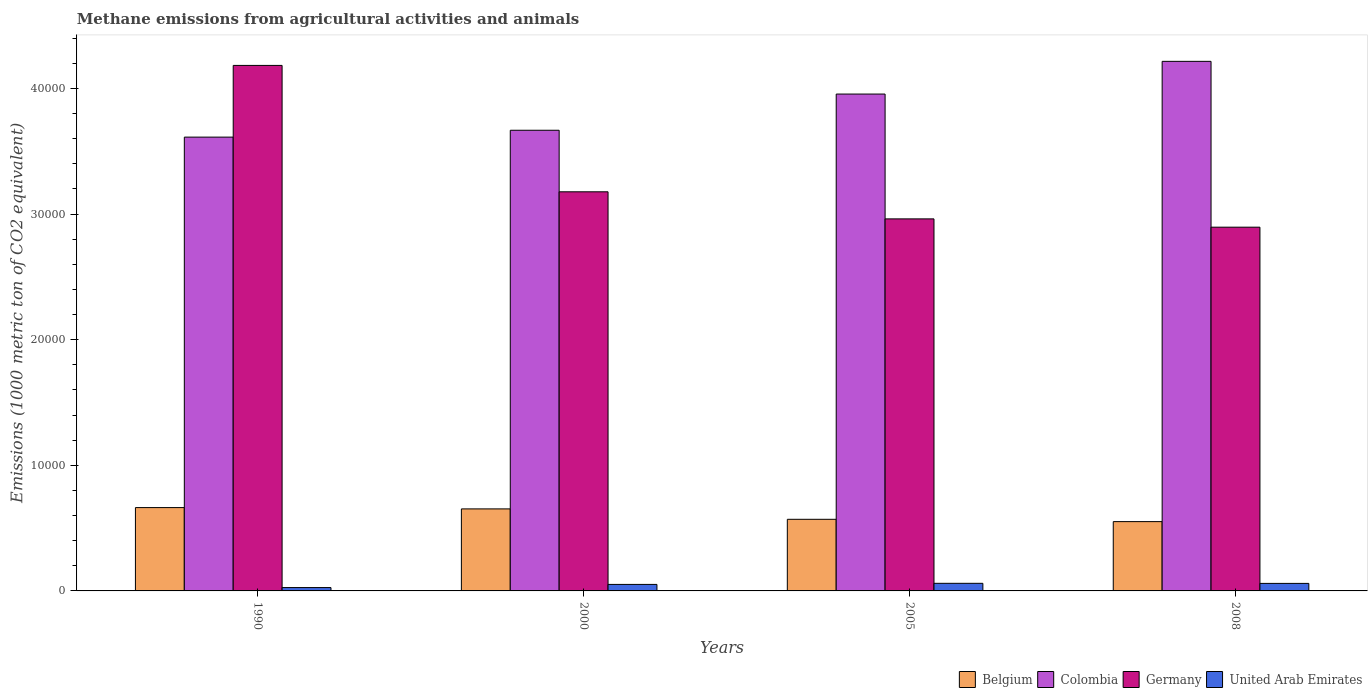Are the number of bars per tick equal to the number of legend labels?
Offer a very short reply. Yes. How many bars are there on the 3rd tick from the left?
Offer a terse response. 4. How many bars are there on the 1st tick from the right?
Give a very brief answer. 4. What is the amount of methane emitted in United Arab Emirates in 2005?
Give a very brief answer. 604.7. Across all years, what is the maximum amount of methane emitted in United Arab Emirates?
Provide a short and direct response. 604.7. Across all years, what is the minimum amount of methane emitted in United Arab Emirates?
Ensure brevity in your answer.  266.3. In which year was the amount of methane emitted in Germany maximum?
Your answer should be very brief. 1990. What is the total amount of methane emitted in Belgium in the graph?
Your response must be concise. 2.44e+04. What is the difference between the amount of methane emitted in Belgium in 1990 and that in 2000?
Provide a short and direct response. 104.8. What is the difference between the amount of methane emitted in Colombia in 2000 and the amount of methane emitted in Belgium in 1990?
Keep it short and to the point. 3.00e+04. What is the average amount of methane emitted in Belgium per year?
Give a very brief answer. 6095.67. In the year 2005, what is the difference between the amount of methane emitted in Belgium and amount of methane emitted in Colombia?
Your answer should be compact. -3.39e+04. What is the ratio of the amount of methane emitted in United Arab Emirates in 2000 to that in 2008?
Make the answer very short. 0.86. Is the amount of methane emitted in Belgium in 1990 less than that in 2008?
Make the answer very short. No. Is the difference between the amount of methane emitted in Belgium in 1990 and 2008 greater than the difference between the amount of methane emitted in Colombia in 1990 and 2008?
Give a very brief answer. Yes. What is the difference between the highest and the second highest amount of methane emitted in Colombia?
Your answer should be very brief. 2603.6. What is the difference between the highest and the lowest amount of methane emitted in Germany?
Your answer should be compact. 1.29e+04. What does the 4th bar from the left in 2005 represents?
Keep it short and to the point. United Arab Emirates. What does the 1st bar from the right in 1990 represents?
Offer a terse response. United Arab Emirates. Are all the bars in the graph horizontal?
Give a very brief answer. No. How many years are there in the graph?
Give a very brief answer. 4. What is the difference between two consecutive major ticks on the Y-axis?
Offer a very short reply. 10000. Does the graph contain grids?
Keep it short and to the point. No. Where does the legend appear in the graph?
Make the answer very short. Bottom right. What is the title of the graph?
Your answer should be compact. Methane emissions from agricultural activities and animals. What is the label or title of the X-axis?
Offer a very short reply. Years. What is the label or title of the Y-axis?
Your answer should be compact. Emissions (1000 metric ton of CO2 equivalent). What is the Emissions (1000 metric ton of CO2 equivalent) in Belgium in 1990?
Ensure brevity in your answer.  6634.3. What is the Emissions (1000 metric ton of CO2 equivalent) in Colombia in 1990?
Keep it short and to the point. 3.61e+04. What is the Emissions (1000 metric ton of CO2 equivalent) in Germany in 1990?
Provide a short and direct response. 4.18e+04. What is the Emissions (1000 metric ton of CO2 equivalent) of United Arab Emirates in 1990?
Keep it short and to the point. 266.3. What is the Emissions (1000 metric ton of CO2 equivalent) of Belgium in 2000?
Your answer should be very brief. 6529.5. What is the Emissions (1000 metric ton of CO2 equivalent) of Colombia in 2000?
Offer a terse response. 3.67e+04. What is the Emissions (1000 metric ton of CO2 equivalent) of Germany in 2000?
Your answer should be very brief. 3.18e+04. What is the Emissions (1000 metric ton of CO2 equivalent) of United Arab Emirates in 2000?
Offer a very short reply. 518. What is the Emissions (1000 metric ton of CO2 equivalent) in Belgium in 2005?
Your answer should be compact. 5701.8. What is the Emissions (1000 metric ton of CO2 equivalent) in Colombia in 2005?
Ensure brevity in your answer.  3.96e+04. What is the Emissions (1000 metric ton of CO2 equivalent) of Germany in 2005?
Make the answer very short. 2.96e+04. What is the Emissions (1000 metric ton of CO2 equivalent) of United Arab Emirates in 2005?
Make the answer very short. 604.7. What is the Emissions (1000 metric ton of CO2 equivalent) in Belgium in 2008?
Your answer should be compact. 5517.1. What is the Emissions (1000 metric ton of CO2 equivalent) in Colombia in 2008?
Offer a very short reply. 4.22e+04. What is the Emissions (1000 metric ton of CO2 equivalent) in Germany in 2008?
Make the answer very short. 2.90e+04. What is the Emissions (1000 metric ton of CO2 equivalent) in United Arab Emirates in 2008?
Provide a short and direct response. 599.2. Across all years, what is the maximum Emissions (1000 metric ton of CO2 equivalent) in Belgium?
Keep it short and to the point. 6634.3. Across all years, what is the maximum Emissions (1000 metric ton of CO2 equivalent) of Colombia?
Offer a very short reply. 4.22e+04. Across all years, what is the maximum Emissions (1000 metric ton of CO2 equivalent) of Germany?
Ensure brevity in your answer.  4.18e+04. Across all years, what is the maximum Emissions (1000 metric ton of CO2 equivalent) in United Arab Emirates?
Give a very brief answer. 604.7. Across all years, what is the minimum Emissions (1000 metric ton of CO2 equivalent) of Belgium?
Your response must be concise. 5517.1. Across all years, what is the minimum Emissions (1000 metric ton of CO2 equivalent) in Colombia?
Offer a terse response. 3.61e+04. Across all years, what is the minimum Emissions (1000 metric ton of CO2 equivalent) in Germany?
Keep it short and to the point. 2.90e+04. Across all years, what is the minimum Emissions (1000 metric ton of CO2 equivalent) in United Arab Emirates?
Make the answer very short. 266.3. What is the total Emissions (1000 metric ton of CO2 equivalent) in Belgium in the graph?
Your answer should be very brief. 2.44e+04. What is the total Emissions (1000 metric ton of CO2 equivalent) of Colombia in the graph?
Keep it short and to the point. 1.55e+05. What is the total Emissions (1000 metric ton of CO2 equivalent) in Germany in the graph?
Your answer should be compact. 1.32e+05. What is the total Emissions (1000 metric ton of CO2 equivalent) in United Arab Emirates in the graph?
Offer a terse response. 1988.2. What is the difference between the Emissions (1000 metric ton of CO2 equivalent) in Belgium in 1990 and that in 2000?
Keep it short and to the point. 104.8. What is the difference between the Emissions (1000 metric ton of CO2 equivalent) of Colombia in 1990 and that in 2000?
Your answer should be compact. -546.7. What is the difference between the Emissions (1000 metric ton of CO2 equivalent) of Germany in 1990 and that in 2000?
Your answer should be very brief. 1.01e+04. What is the difference between the Emissions (1000 metric ton of CO2 equivalent) in United Arab Emirates in 1990 and that in 2000?
Ensure brevity in your answer.  -251.7. What is the difference between the Emissions (1000 metric ton of CO2 equivalent) of Belgium in 1990 and that in 2005?
Give a very brief answer. 932.5. What is the difference between the Emissions (1000 metric ton of CO2 equivalent) in Colombia in 1990 and that in 2005?
Your answer should be very brief. -3428.3. What is the difference between the Emissions (1000 metric ton of CO2 equivalent) in Germany in 1990 and that in 2005?
Your answer should be compact. 1.22e+04. What is the difference between the Emissions (1000 metric ton of CO2 equivalent) in United Arab Emirates in 1990 and that in 2005?
Offer a terse response. -338.4. What is the difference between the Emissions (1000 metric ton of CO2 equivalent) of Belgium in 1990 and that in 2008?
Offer a very short reply. 1117.2. What is the difference between the Emissions (1000 metric ton of CO2 equivalent) in Colombia in 1990 and that in 2008?
Keep it short and to the point. -6031.9. What is the difference between the Emissions (1000 metric ton of CO2 equivalent) of Germany in 1990 and that in 2008?
Provide a short and direct response. 1.29e+04. What is the difference between the Emissions (1000 metric ton of CO2 equivalent) of United Arab Emirates in 1990 and that in 2008?
Make the answer very short. -332.9. What is the difference between the Emissions (1000 metric ton of CO2 equivalent) of Belgium in 2000 and that in 2005?
Your answer should be compact. 827.7. What is the difference between the Emissions (1000 metric ton of CO2 equivalent) of Colombia in 2000 and that in 2005?
Your answer should be compact. -2881.6. What is the difference between the Emissions (1000 metric ton of CO2 equivalent) in Germany in 2000 and that in 2005?
Make the answer very short. 2155.4. What is the difference between the Emissions (1000 metric ton of CO2 equivalent) in United Arab Emirates in 2000 and that in 2005?
Make the answer very short. -86.7. What is the difference between the Emissions (1000 metric ton of CO2 equivalent) in Belgium in 2000 and that in 2008?
Your answer should be compact. 1012.4. What is the difference between the Emissions (1000 metric ton of CO2 equivalent) in Colombia in 2000 and that in 2008?
Your answer should be very brief. -5485.2. What is the difference between the Emissions (1000 metric ton of CO2 equivalent) in Germany in 2000 and that in 2008?
Your answer should be very brief. 2816.4. What is the difference between the Emissions (1000 metric ton of CO2 equivalent) of United Arab Emirates in 2000 and that in 2008?
Keep it short and to the point. -81.2. What is the difference between the Emissions (1000 metric ton of CO2 equivalent) of Belgium in 2005 and that in 2008?
Offer a terse response. 184.7. What is the difference between the Emissions (1000 metric ton of CO2 equivalent) in Colombia in 2005 and that in 2008?
Offer a terse response. -2603.6. What is the difference between the Emissions (1000 metric ton of CO2 equivalent) of Germany in 2005 and that in 2008?
Keep it short and to the point. 661. What is the difference between the Emissions (1000 metric ton of CO2 equivalent) of United Arab Emirates in 2005 and that in 2008?
Offer a very short reply. 5.5. What is the difference between the Emissions (1000 metric ton of CO2 equivalent) of Belgium in 1990 and the Emissions (1000 metric ton of CO2 equivalent) of Colombia in 2000?
Your answer should be compact. -3.00e+04. What is the difference between the Emissions (1000 metric ton of CO2 equivalent) of Belgium in 1990 and the Emissions (1000 metric ton of CO2 equivalent) of Germany in 2000?
Give a very brief answer. -2.51e+04. What is the difference between the Emissions (1000 metric ton of CO2 equivalent) in Belgium in 1990 and the Emissions (1000 metric ton of CO2 equivalent) in United Arab Emirates in 2000?
Give a very brief answer. 6116.3. What is the difference between the Emissions (1000 metric ton of CO2 equivalent) of Colombia in 1990 and the Emissions (1000 metric ton of CO2 equivalent) of Germany in 2000?
Your answer should be very brief. 4353.5. What is the difference between the Emissions (1000 metric ton of CO2 equivalent) of Colombia in 1990 and the Emissions (1000 metric ton of CO2 equivalent) of United Arab Emirates in 2000?
Your answer should be compact. 3.56e+04. What is the difference between the Emissions (1000 metric ton of CO2 equivalent) in Germany in 1990 and the Emissions (1000 metric ton of CO2 equivalent) in United Arab Emirates in 2000?
Offer a terse response. 4.13e+04. What is the difference between the Emissions (1000 metric ton of CO2 equivalent) of Belgium in 1990 and the Emissions (1000 metric ton of CO2 equivalent) of Colombia in 2005?
Offer a terse response. -3.29e+04. What is the difference between the Emissions (1000 metric ton of CO2 equivalent) in Belgium in 1990 and the Emissions (1000 metric ton of CO2 equivalent) in Germany in 2005?
Your answer should be compact. -2.30e+04. What is the difference between the Emissions (1000 metric ton of CO2 equivalent) in Belgium in 1990 and the Emissions (1000 metric ton of CO2 equivalent) in United Arab Emirates in 2005?
Make the answer very short. 6029.6. What is the difference between the Emissions (1000 metric ton of CO2 equivalent) of Colombia in 1990 and the Emissions (1000 metric ton of CO2 equivalent) of Germany in 2005?
Your response must be concise. 6508.9. What is the difference between the Emissions (1000 metric ton of CO2 equivalent) of Colombia in 1990 and the Emissions (1000 metric ton of CO2 equivalent) of United Arab Emirates in 2005?
Make the answer very short. 3.55e+04. What is the difference between the Emissions (1000 metric ton of CO2 equivalent) in Germany in 1990 and the Emissions (1000 metric ton of CO2 equivalent) in United Arab Emirates in 2005?
Your response must be concise. 4.12e+04. What is the difference between the Emissions (1000 metric ton of CO2 equivalent) in Belgium in 1990 and the Emissions (1000 metric ton of CO2 equivalent) in Colombia in 2008?
Your answer should be very brief. -3.55e+04. What is the difference between the Emissions (1000 metric ton of CO2 equivalent) in Belgium in 1990 and the Emissions (1000 metric ton of CO2 equivalent) in Germany in 2008?
Your answer should be very brief. -2.23e+04. What is the difference between the Emissions (1000 metric ton of CO2 equivalent) of Belgium in 1990 and the Emissions (1000 metric ton of CO2 equivalent) of United Arab Emirates in 2008?
Your response must be concise. 6035.1. What is the difference between the Emissions (1000 metric ton of CO2 equivalent) in Colombia in 1990 and the Emissions (1000 metric ton of CO2 equivalent) in Germany in 2008?
Keep it short and to the point. 7169.9. What is the difference between the Emissions (1000 metric ton of CO2 equivalent) in Colombia in 1990 and the Emissions (1000 metric ton of CO2 equivalent) in United Arab Emirates in 2008?
Provide a succinct answer. 3.55e+04. What is the difference between the Emissions (1000 metric ton of CO2 equivalent) of Germany in 1990 and the Emissions (1000 metric ton of CO2 equivalent) of United Arab Emirates in 2008?
Your answer should be very brief. 4.12e+04. What is the difference between the Emissions (1000 metric ton of CO2 equivalent) of Belgium in 2000 and the Emissions (1000 metric ton of CO2 equivalent) of Colombia in 2005?
Your response must be concise. -3.30e+04. What is the difference between the Emissions (1000 metric ton of CO2 equivalent) in Belgium in 2000 and the Emissions (1000 metric ton of CO2 equivalent) in Germany in 2005?
Your answer should be very brief. -2.31e+04. What is the difference between the Emissions (1000 metric ton of CO2 equivalent) of Belgium in 2000 and the Emissions (1000 metric ton of CO2 equivalent) of United Arab Emirates in 2005?
Give a very brief answer. 5924.8. What is the difference between the Emissions (1000 metric ton of CO2 equivalent) in Colombia in 2000 and the Emissions (1000 metric ton of CO2 equivalent) in Germany in 2005?
Keep it short and to the point. 7055.6. What is the difference between the Emissions (1000 metric ton of CO2 equivalent) of Colombia in 2000 and the Emissions (1000 metric ton of CO2 equivalent) of United Arab Emirates in 2005?
Provide a succinct answer. 3.61e+04. What is the difference between the Emissions (1000 metric ton of CO2 equivalent) of Germany in 2000 and the Emissions (1000 metric ton of CO2 equivalent) of United Arab Emirates in 2005?
Give a very brief answer. 3.12e+04. What is the difference between the Emissions (1000 metric ton of CO2 equivalent) in Belgium in 2000 and the Emissions (1000 metric ton of CO2 equivalent) in Colombia in 2008?
Your answer should be very brief. -3.56e+04. What is the difference between the Emissions (1000 metric ton of CO2 equivalent) in Belgium in 2000 and the Emissions (1000 metric ton of CO2 equivalent) in Germany in 2008?
Make the answer very short. -2.24e+04. What is the difference between the Emissions (1000 metric ton of CO2 equivalent) of Belgium in 2000 and the Emissions (1000 metric ton of CO2 equivalent) of United Arab Emirates in 2008?
Your answer should be very brief. 5930.3. What is the difference between the Emissions (1000 metric ton of CO2 equivalent) of Colombia in 2000 and the Emissions (1000 metric ton of CO2 equivalent) of Germany in 2008?
Your response must be concise. 7716.6. What is the difference between the Emissions (1000 metric ton of CO2 equivalent) in Colombia in 2000 and the Emissions (1000 metric ton of CO2 equivalent) in United Arab Emirates in 2008?
Offer a very short reply. 3.61e+04. What is the difference between the Emissions (1000 metric ton of CO2 equivalent) of Germany in 2000 and the Emissions (1000 metric ton of CO2 equivalent) of United Arab Emirates in 2008?
Your response must be concise. 3.12e+04. What is the difference between the Emissions (1000 metric ton of CO2 equivalent) in Belgium in 2005 and the Emissions (1000 metric ton of CO2 equivalent) in Colombia in 2008?
Your answer should be very brief. -3.65e+04. What is the difference between the Emissions (1000 metric ton of CO2 equivalent) in Belgium in 2005 and the Emissions (1000 metric ton of CO2 equivalent) in Germany in 2008?
Your answer should be very brief. -2.33e+04. What is the difference between the Emissions (1000 metric ton of CO2 equivalent) of Belgium in 2005 and the Emissions (1000 metric ton of CO2 equivalent) of United Arab Emirates in 2008?
Keep it short and to the point. 5102.6. What is the difference between the Emissions (1000 metric ton of CO2 equivalent) of Colombia in 2005 and the Emissions (1000 metric ton of CO2 equivalent) of Germany in 2008?
Your answer should be very brief. 1.06e+04. What is the difference between the Emissions (1000 metric ton of CO2 equivalent) in Colombia in 2005 and the Emissions (1000 metric ton of CO2 equivalent) in United Arab Emirates in 2008?
Make the answer very short. 3.90e+04. What is the difference between the Emissions (1000 metric ton of CO2 equivalent) of Germany in 2005 and the Emissions (1000 metric ton of CO2 equivalent) of United Arab Emirates in 2008?
Offer a very short reply. 2.90e+04. What is the average Emissions (1000 metric ton of CO2 equivalent) in Belgium per year?
Offer a very short reply. 6095.68. What is the average Emissions (1000 metric ton of CO2 equivalent) of Colombia per year?
Ensure brevity in your answer.  3.86e+04. What is the average Emissions (1000 metric ton of CO2 equivalent) of Germany per year?
Your answer should be compact. 3.30e+04. What is the average Emissions (1000 metric ton of CO2 equivalent) in United Arab Emirates per year?
Ensure brevity in your answer.  497.05. In the year 1990, what is the difference between the Emissions (1000 metric ton of CO2 equivalent) in Belgium and Emissions (1000 metric ton of CO2 equivalent) in Colombia?
Make the answer very short. -2.95e+04. In the year 1990, what is the difference between the Emissions (1000 metric ton of CO2 equivalent) in Belgium and Emissions (1000 metric ton of CO2 equivalent) in Germany?
Your response must be concise. -3.52e+04. In the year 1990, what is the difference between the Emissions (1000 metric ton of CO2 equivalent) in Belgium and Emissions (1000 metric ton of CO2 equivalent) in United Arab Emirates?
Your response must be concise. 6368. In the year 1990, what is the difference between the Emissions (1000 metric ton of CO2 equivalent) in Colombia and Emissions (1000 metric ton of CO2 equivalent) in Germany?
Your answer should be very brief. -5708.5. In the year 1990, what is the difference between the Emissions (1000 metric ton of CO2 equivalent) of Colombia and Emissions (1000 metric ton of CO2 equivalent) of United Arab Emirates?
Give a very brief answer. 3.59e+04. In the year 1990, what is the difference between the Emissions (1000 metric ton of CO2 equivalent) in Germany and Emissions (1000 metric ton of CO2 equivalent) in United Arab Emirates?
Provide a short and direct response. 4.16e+04. In the year 2000, what is the difference between the Emissions (1000 metric ton of CO2 equivalent) in Belgium and Emissions (1000 metric ton of CO2 equivalent) in Colombia?
Keep it short and to the point. -3.01e+04. In the year 2000, what is the difference between the Emissions (1000 metric ton of CO2 equivalent) of Belgium and Emissions (1000 metric ton of CO2 equivalent) of Germany?
Keep it short and to the point. -2.52e+04. In the year 2000, what is the difference between the Emissions (1000 metric ton of CO2 equivalent) of Belgium and Emissions (1000 metric ton of CO2 equivalent) of United Arab Emirates?
Your answer should be very brief. 6011.5. In the year 2000, what is the difference between the Emissions (1000 metric ton of CO2 equivalent) of Colombia and Emissions (1000 metric ton of CO2 equivalent) of Germany?
Ensure brevity in your answer.  4900.2. In the year 2000, what is the difference between the Emissions (1000 metric ton of CO2 equivalent) of Colombia and Emissions (1000 metric ton of CO2 equivalent) of United Arab Emirates?
Provide a short and direct response. 3.62e+04. In the year 2000, what is the difference between the Emissions (1000 metric ton of CO2 equivalent) in Germany and Emissions (1000 metric ton of CO2 equivalent) in United Arab Emirates?
Your response must be concise. 3.13e+04. In the year 2005, what is the difference between the Emissions (1000 metric ton of CO2 equivalent) of Belgium and Emissions (1000 metric ton of CO2 equivalent) of Colombia?
Keep it short and to the point. -3.39e+04. In the year 2005, what is the difference between the Emissions (1000 metric ton of CO2 equivalent) in Belgium and Emissions (1000 metric ton of CO2 equivalent) in Germany?
Offer a terse response. -2.39e+04. In the year 2005, what is the difference between the Emissions (1000 metric ton of CO2 equivalent) of Belgium and Emissions (1000 metric ton of CO2 equivalent) of United Arab Emirates?
Your response must be concise. 5097.1. In the year 2005, what is the difference between the Emissions (1000 metric ton of CO2 equivalent) in Colombia and Emissions (1000 metric ton of CO2 equivalent) in Germany?
Offer a very short reply. 9937.2. In the year 2005, what is the difference between the Emissions (1000 metric ton of CO2 equivalent) in Colombia and Emissions (1000 metric ton of CO2 equivalent) in United Arab Emirates?
Your response must be concise. 3.90e+04. In the year 2005, what is the difference between the Emissions (1000 metric ton of CO2 equivalent) of Germany and Emissions (1000 metric ton of CO2 equivalent) of United Arab Emirates?
Offer a terse response. 2.90e+04. In the year 2008, what is the difference between the Emissions (1000 metric ton of CO2 equivalent) in Belgium and Emissions (1000 metric ton of CO2 equivalent) in Colombia?
Give a very brief answer. -3.66e+04. In the year 2008, what is the difference between the Emissions (1000 metric ton of CO2 equivalent) in Belgium and Emissions (1000 metric ton of CO2 equivalent) in Germany?
Ensure brevity in your answer.  -2.34e+04. In the year 2008, what is the difference between the Emissions (1000 metric ton of CO2 equivalent) of Belgium and Emissions (1000 metric ton of CO2 equivalent) of United Arab Emirates?
Provide a short and direct response. 4917.9. In the year 2008, what is the difference between the Emissions (1000 metric ton of CO2 equivalent) in Colombia and Emissions (1000 metric ton of CO2 equivalent) in Germany?
Provide a short and direct response. 1.32e+04. In the year 2008, what is the difference between the Emissions (1000 metric ton of CO2 equivalent) in Colombia and Emissions (1000 metric ton of CO2 equivalent) in United Arab Emirates?
Keep it short and to the point. 4.16e+04. In the year 2008, what is the difference between the Emissions (1000 metric ton of CO2 equivalent) in Germany and Emissions (1000 metric ton of CO2 equivalent) in United Arab Emirates?
Provide a succinct answer. 2.84e+04. What is the ratio of the Emissions (1000 metric ton of CO2 equivalent) in Belgium in 1990 to that in 2000?
Provide a short and direct response. 1.02. What is the ratio of the Emissions (1000 metric ton of CO2 equivalent) in Colombia in 1990 to that in 2000?
Keep it short and to the point. 0.99. What is the ratio of the Emissions (1000 metric ton of CO2 equivalent) in Germany in 1990 to that in 2000?
Offer a very short reply. 1.32. What is the ratio of the Emissions (1000 metric ton of CO2 equivalent) of United Arab Emirates in 1990 to that in 2000?
Offer a very short reply. 0.51. What is the ratio of the Emissions (1000 metric ton of CO2 equivalent) in Belgium in 1990 to that in 2005?
Your answer should be compact. 1.16. What is the ratio of the Emissions (1000 metric ton of CO2 equivalent) in Colombia in 1990 to that in 2005?
Offer a terse response. 0.91. What is the ratio of the Emissions (1000 metric ton of CO2 equivalent) in Germany in 1990 to that in 2005?
Provide a short and direct response. 1.41. What is the ratio of the Emissions (1000 metric ton of CO2 equivalent) of United Arab Emirates in 1990 to that in 2005?
Your answer should be very brief. 0.44. What is the ratio of the Emissions (1000 metric ton of CO2 equivalent) of Belgium in 1990 to that in 2008?
Keep it short and to the point. 1.2. What is the ratio of the Emissions (1000 metric ton of CO2 equivalent) of Colombia in 1990 to that in 2008?
Your answer should be very brief. 0.86. What is the ratio of the Emissions (1000 metric ton of CO2 equivalent) of Germany in 1990 to that in 2008?
Provide a succinct answer. 1.44. What is the ratio of the Emissions (1000 metric ton of CO2 equivalent) of United Arab Emirates in 1990 to that in 2008?
Give a very brief answer. 0.44. What is the ratio of the Emissions (1000 metric ton of CO2 equivalent) in Belgium in 2000 to that in 2005?
Ensure brevity in your answer.  1.15. What is the ratio of the Emissions (1000 metric ton of CO2 equivalent) of Colombia in 2000 to that in 2005?
Your response must be concise. 0.93. What is the ratio of the Emissions (1000 metric ton of CO2 equivalent) of Germany in 2000 to that in 2005?
Provide a succinct answer. 1.07. What is the ratio of the Emissions (1000 metric ton of CO2 equivalent) in United Arab Emirates in 2000 to that in 2005?
Ensure brevity in your answer.  0.86. What is the ratio of the Emissions (1000 metric ton of CO2 equivalent) of Belgium in 2000 to that in 2008?
Give a very brief answer. 1.18. What is the ratio of the Emissions (1000 metric ton of CO2 equivalent) in Colombia in 2000 to that in 2008?
Provide a short and direct response. 0.87. What is the ratio of the Emissions (1000 metric ton of CO2 equivalent) of Germany in 2000 to that in 2008?
Keep it short and to the point. 1.1. What is the ratio of the Emissions (1000 metric ton of CO2 equivalent) of United Arab Emirates in 2000 to that in 2008?
Offer a very short reply. 0.86. What is the ratio of the Emissions (1000 metric ton of CO2 equivalent) of Belgium in 2005 to that in 2008?
Offer a terse response. 1.03. What is the ratio of the Emissions (1000 metric ton of CO2 equivalent) in Colombia in 2005 to that in 2008?
Provide a succinct answer. 0.94. What is the ratio of the Emissions (1000 metric ton of CO2 equivalent) of Germany in 2005 to that in 2008?
Your answer should be compact. 1.02. What is the ratio of the Emissions (1000 metric ton of CO2 equivalent) of United Arab Emirates in 2005 to that in 2008?
Your answer should be very brief. 1.01. What is the difference between the highest and the second highest Emissions (1000 metric ton of CO2 equivalent) in Belgium?
Provide a succinct answer. 104.8. What is the difference between the highest and the second highest Emissions (1000 metric ton of CO2 equivalent) of Colombia?
Offer a terse response. 2603.6. What is the difference between the highest and the second highest Emissions (1000 metric ton of CO2 equivalent) in Germany?
Offer a very short reply. 1.01e+04. What is the difference between the highest and the lowest Emissions (1000 metric ton of CO2 equivalent) of Belgium?
Your answer should be very brief. 1117.2. What is the difference between the highest and the lowest Emissions (1000 metric ton of CO2 equivalent) in Colombia?
Offer a terse response. 6031.9. What is the difference between the highest and the lowest Emissions (1000 metric ton of CO2 equivalent) of Germany?
Ensure brevity in your answer.  1.29e+04. What is the difference between the highest and the lowest Emissions (1000 metric ton of CO2 equivalent) of United Arab Emirates?
Offer a very short reply. 338.4. 